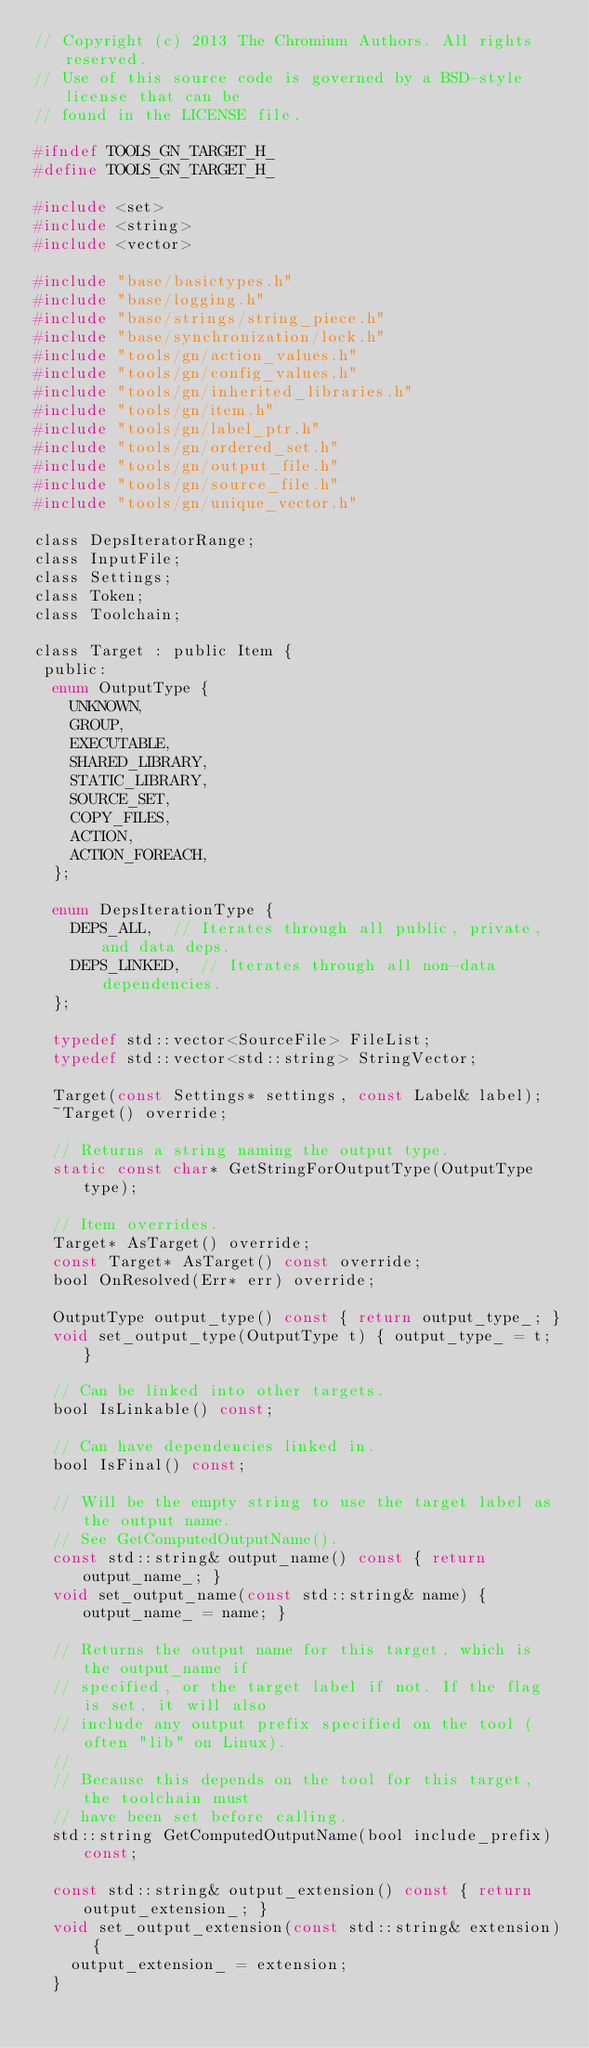<code> <loc_0><loc_0><loc_500><loc_500><_C_>// Copyright (c) 2013 The Chromium Authors. All rights reserved.
// Use of this source code is governed by a BSD-style license that can be
// found in the LICENSE file.

#ifndef TOOLS_GN_TARGET_H_
#define TOOLS_GN_TARGET_H_

#include <set>
#include <string>
#include <vector>

#include "base/basictypes.h"
#include "base/logging.h"
#include "base/strings/string_piece.h"
#include "base/synchronization/lock.h"
#include "tools/gn/action_values.h"
#include "tools/gn/config_values.h"
#include "tools/gn/inherited_libraries.h"
#include "tools/gn/item.h"
#include "tools/gn/label_ptr.h"
#include "tools/gn/ordered_set.h"
#include "tools/gn/output_file.h"
#include "tools/gn/source_file.h"
#include "tools/gn/unique_vector.h"

class DepsIteratorRange;
class InputFile;
class Settings;
class Token;
class Toolchain;

class Target : public Item {
 public:
  enum OutputType {
    UNKNOWN,
    GROUP,
    EXECUTABLE,
    SHARED_LIBRARY,
    STATIC_LIBRARY,
    SOURCE_SET,
    COPY_FILES,
    ACTION,
    ACTION_FOREACH,
  };

  enum DepsIterationType {
    DEPS_ALL,  // Iterates through all public, private, and data deps.
    DEPS_LINKED,  // Iterates through all non-data dependencies.
  };

  typedef std::vector<SourceFile> FileList;
  typedef std::vector<std::string> StringVector;

  Target(const Settings* settings, const Label& label);
  ~Target() override;

  // Returns a string naming the output type.
  static const char* GetStringForOutputType(OutputType type);

  // Item overrides.
  Target* AsTarget() override;
  const Target* AsTarget() const override;
  bool OnResolved(Err* err) override;

  OutputType output_type() const { return output_type_; }
  void set_output_type(OutputType t) { output_type_ = t; }

  // Can be linked into other targets.
  bool IsLinkable() const;

  // Can have dependencies linked in.
  bool IsFinal() const;

  // Will be the empty string to use the target label as the output name.
  // See GetComputedOutputName().
  const std::string& output_name() const { return output_name_; }
  void set_output_name(const std::string& name) { output_name_ = name; }

  // Returns the output name for this target, which is the output_name if
  // specified, or the target label if not. If the flag is set, it will also
  // include any output prefix specified on the tool (often "lib" on Linux).
  //
  // Because this depends on the tool for this target, the toolchain must
  // have been set before calling.
  std::string GetComputedOutputName(bool include_prefix) const;

  const std::string& output_extension() const { return output_extension_; }
  void set_output_extension(const std::string& extension) {
    output_extension_ = extension;
  }
</code> 